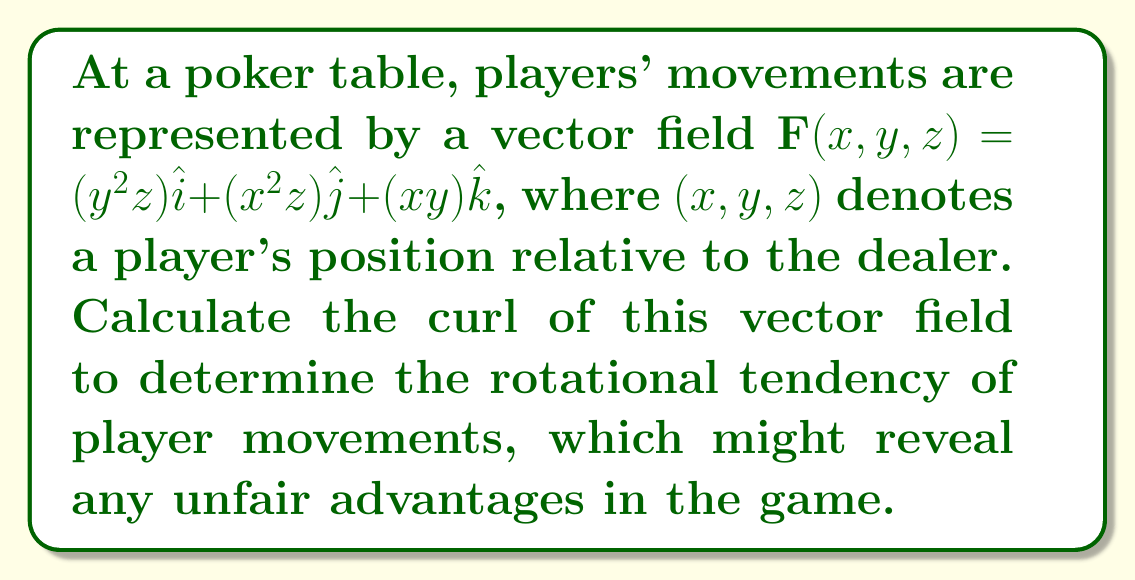Can you answer this question? To find the curl of the vector field, we need to calculate:

$$\text{curl }\mathbf{F} = \nabla \times \mathbf{F} = \left(\frac{\partial F_z}{\partial y} - \frac{\partial F_y}{\partial z}\right)\hat{i} + \left(\frac{\partial F_x}{\partial z} - \frac{\partial F_z}{\partial x}\right)\hat{j} + \left(\frac{\partial F_y}{\partial x} - \frac{\partial F_x}{\partial y}\right)\hat{k}$$

Let's calculate each component:

1. $\hat{i}$ component:
   $\frac{\partial F_z}{\partial y} - \frac{\partial F_y}{\partial z} = \frac{\partial (xy)}{\partial y} - \frac{\partial (x^2z)}{\partial z} = x - x^2 = x - x^2$

2. $\hat{j}$ component:
   $\frac{\partial F_x}{\partial z} - \frac{\partial F_z}{\partial x} = \frac{\partial (y^2z)}{\partial z} - \frac{\partial (xy)}{\partial x} = y^2 - y = y^2 - y$

3. $\hat{k}$ component:
   $\frac{\partial F_y}{\partial x} - \frac{\partial F_x}{\partial y} = \frac{\partial (x^2z)}{\partial x} - \frac{\partial (y^2z)}{\partial y} = 2xz - 2yz = 2z(x-y)$

Therefore, the curl of the vector field is:

$$\text{curl }\mathbf{F} = (x - x^2)\hat{i} + (y^2 - y)\hat{j} + 2z(x-y)\hat{k}$$
Answer: $(x - x^2)\hat{i} + (y^2 - y)\hat{j} + 2z(x-y)\hat{k}$ 